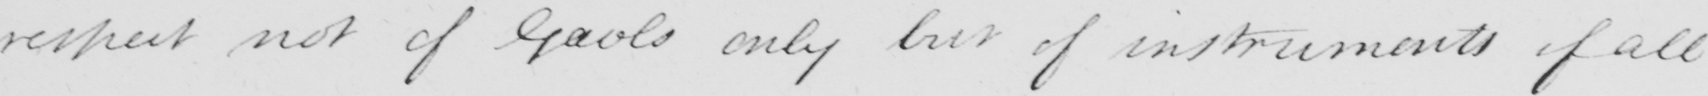Can you read and transcribe this handwriting? respect not of Gaols only but of instruments of all 